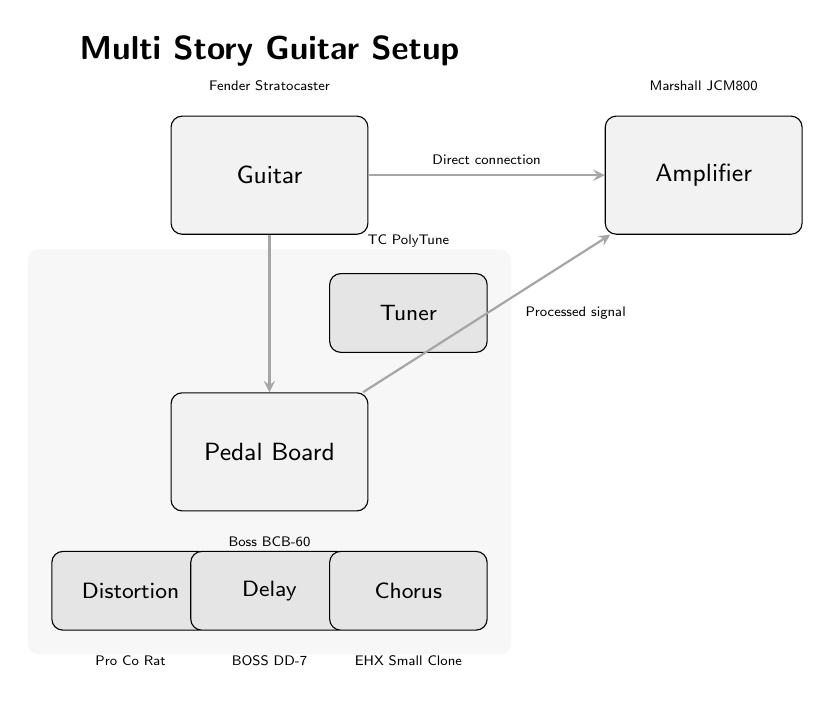What type of guitar is used in the setup? The diagram shows a label above the guitar node indicating "Fender Stratocaster," which is the specific type of guitar in the setup.
Answer: Fender Stratocaster What is the name of the amplifier in the setup? Above the amplifier node, there is a label stating "Marshall JCM800," which identifies the specific amplifier used in this guitar setup.
Answer: Marshall JCM800 How many effects pedals are shown in the diagram? The diagram displays four distinct pedal nodes: Distortion, Delay, Chorus, and Tuner, which are counted for the total number of pedals.
Answer: four What is the first element that the guitar connects to in the setup? The connection arrow shows that the guitar node connects directly to the pedal board before any other equipment, indicating the order of connection.
Answer: Pedal Board What effect does the "Distortion" pedal represent? The text inside the "Distortion" pedal node indicates it is labeled as "Pro Co Rat," which identifies the pedal's specific effect within the diagram's context.
Answer: Pro Co Rat What type of connection does the guitar have with the amplifier? The label on the connection line between the guitar and amplifier explicitly states "Direct connection," defining the nature of their relationship in the setup.
Answer: Direct connection What comes after the pedal board in the signal chain? The arrow connection leads from the pedal board to the amplifier, which shows the processed signal flowing from the pedal board to the amplifier as the next step.
Answer: Amplifier Which pedal is associated with delay effects? The node labeled "Delay" in the pedal section specifies the type of effects it represents, simplifying the identification of effect types in the diagram.
Answer: BOSS DD-7 What is the order of pedals as presented in the diagram from left to right starting from the pedal board? The pedals are arranged in a vertical layout, and moving down from the pedal board, the order is Distortion, Delay, Chorus, with Distortion as the first.
Answer: Distortion, Delay, Chorus 